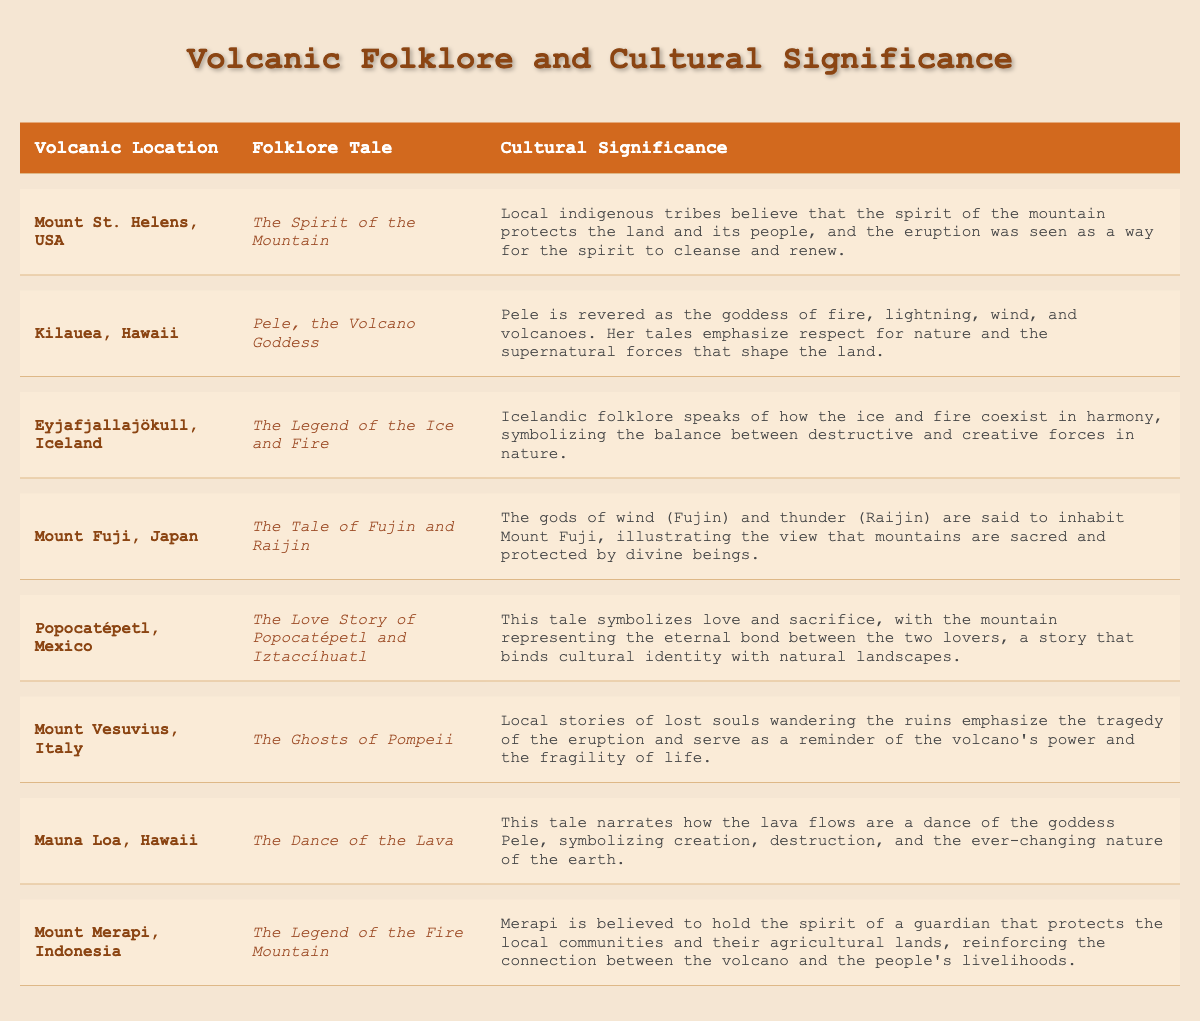What is the folklore tale associated with Mount St. Helens? The table lists <i>The Spirit of the Mountain</i> as the folklore tale for Mount St. Helens.
Answer: The Spirit of the Mountain Which volcanic location is associated with the goddess Pele? According to the table, Kilauea, Hawaii is associated with the goddess Pele.
Answer: Kilauea, Hawaii What is the cultural significance of Eyjafjallajökull's folklore? The table indicates that the cultural significance highlights the harmony of ice and fire, symbolizing balance in nature.
Answer: Balance between destructive and creative forces Is *The Love Story of Popocatépetl and Iztaccíhuatl* related to cultural identity? Yes, the table confirms that the tale binds cultural identity with natural landscapes.
Answer: Yes Are there any volcanoes in the table that have folklore related to love? Yes, the table mentions Popocatépetl and Iztaccíhuatl, which symbolizes love and sacrifice.
Answer: Yes Which volcanic location emphasizes respect for nature and supernatural forces? The folklore of Kilauea emphasizes respect for nature and the supernatural as per the table.
Answer: Kilauea What volcanic tale refers to the tragedy of Pompeii? According to the table, *The Ghosts of Pompeii* refers to the tragedy of the eruption.
Answer: The Ghosts of Pompeii How many different folklore tales are mentioned in the table? The table lists a total of eight different folklore tales associated with various volcanic locations.
Answer: Eight Does Mount Merapi have a folklore tale related to agricultural protection? Yes, the table states that Merapi is believed to protect local agricultural lands.
Answer: Yes Which two volcanic locations are associated with tales of divine beings? The table identifies Mount Fuji and Kilauea as locations associated with divine beings.
Answer: Mount Fuji and Kilauea What is the relationship between the folklore of Mauna Loa and the concept of change? The tale describes the lava flows as a dance, symbolizing creation, destruction, and change in nature.
Answer: Creation, destruction, and change Can you name a volcanic folklore that highlights the coexistence of destructive and creative forces? The table presents *The Legend of the Ice and Fire* from Eyjafjallajökull as highlighting this coexistence.
Answer: The Legend of the Ice and Fire What does the tale of Fujin and Raijin illustrate about mountains? The table states that the tale illustrates that mountains are sacred and inhabited by divine beings.
Answer: Mountains are sacred How does the folklore of Popocatépetl and Iztaccíhuatl express the theme of sacrifice? The table notes that their love story symbolizes love and sacrifice, linking it to cultural identity.
Answer: Love and sacrifice Which folklore involves tales of lost souls and serves as a reminder of the volcano's power? The folklore titled *The Ghosts of Pompeii* involves lost souls and emphasizes the volcano's power.
Answer: The Ghosts of Pompeii Explain the relationship between the cultural significance of Mount Merapi and local communities. The table mentions that Mount Merapi is believed to hold a guardian spirit that protects local communities and their lands.
Answer: Guardian spirit protects local communities 